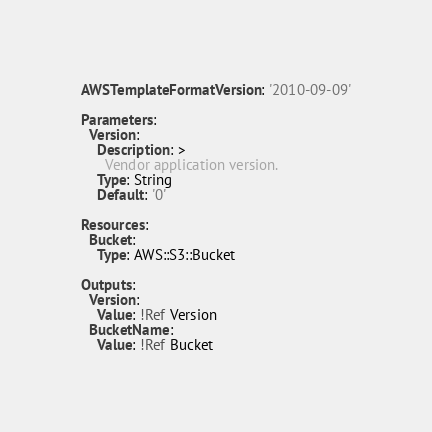<code> <loc_0><loc_0><loc_500><loc_500><_YAML_>AWSTemplateFormatVersion: '2010-09-09'

Parameters:
  Version:
    Description: >
      Vendor application version.
    Type: String
    Default: '0'

Resources:
  Bucket:
    Type: AWS::S3::Bucket

Outputs:
  Version:
    Value: !Ref Version
  BucketName:
    Value: !Ref Bucket
</code> 